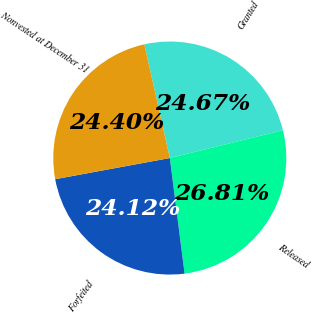Convert chart. <chart><loc_0><loc_0><loc_500><loc_500><pie_chart><fcel>Granted<fcel>Released<fcel>Forfeited<fcel>Nonvested at December 31<nl><fcel>24.67%<fcel>26.81%<fcel>24.12%<fcel>24.4%<nl></chart> 